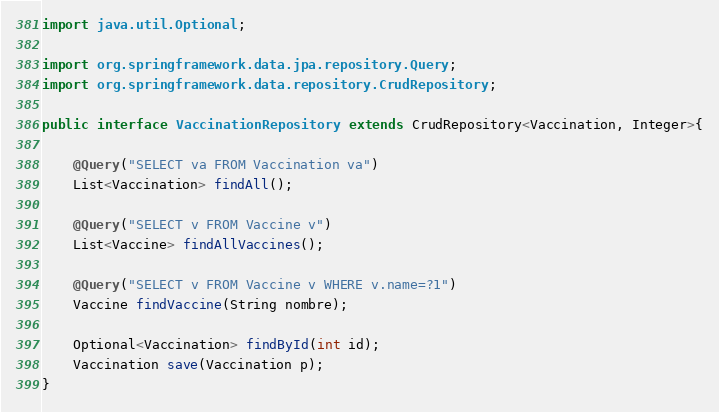<code> <loc_0><loc_0><loc_500><loc_500><_Java_>import java.util.Optional;

import org.springframework.data.jpa.repository.Query;
import org.springframework.data.repository.CrudRepository;

public interface VaccinationRepository extends CrudRepository<Vaccination, Integer>{
    
	@Query("SELECT va FROM Vaccination va")
	List<Vaccination> findAll();
    
    @Query("SELECT v FROM Vaccine v")
    List<Vaccine> findAllVaccines();
    
    @Query("SELECT v FROM Vaccine v WHERE v.name=?1")
    Vaccine findVaccine(String nombre);
    
    Optional<Vaccination> findById(int id);
    Vaccination save(Vaccination p);
}


</code> 